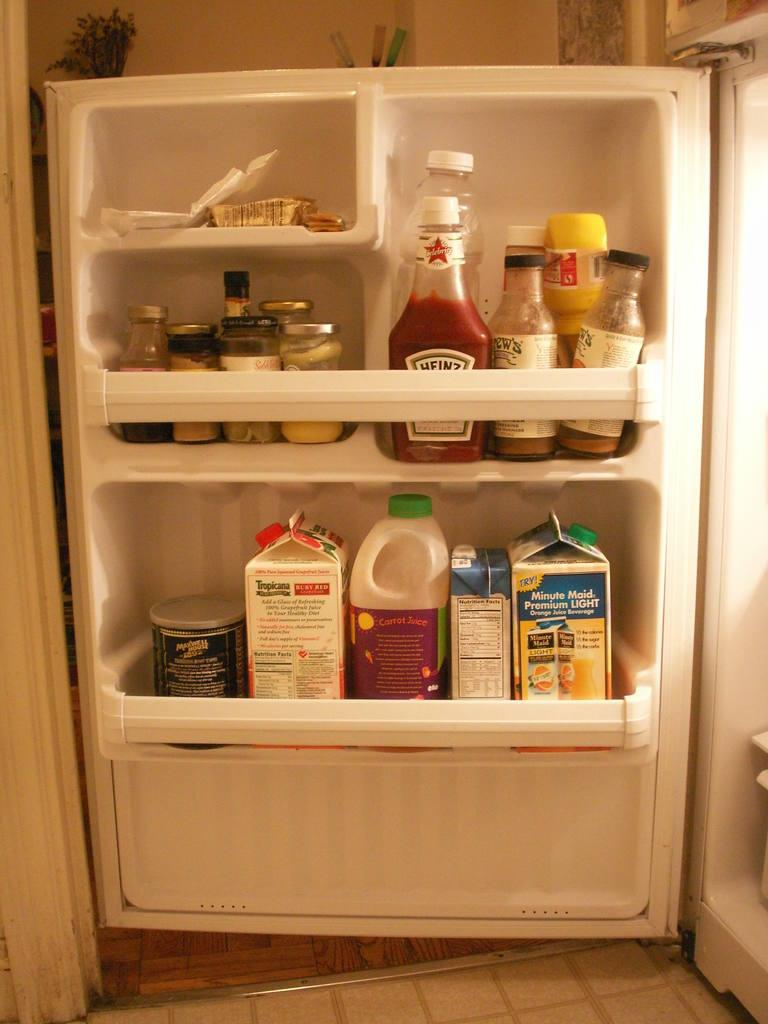<image>
Give a short and clear explanation of the subsequent image. A refrigerator door has cartons of milk and Tropicana stored on the shelf. 